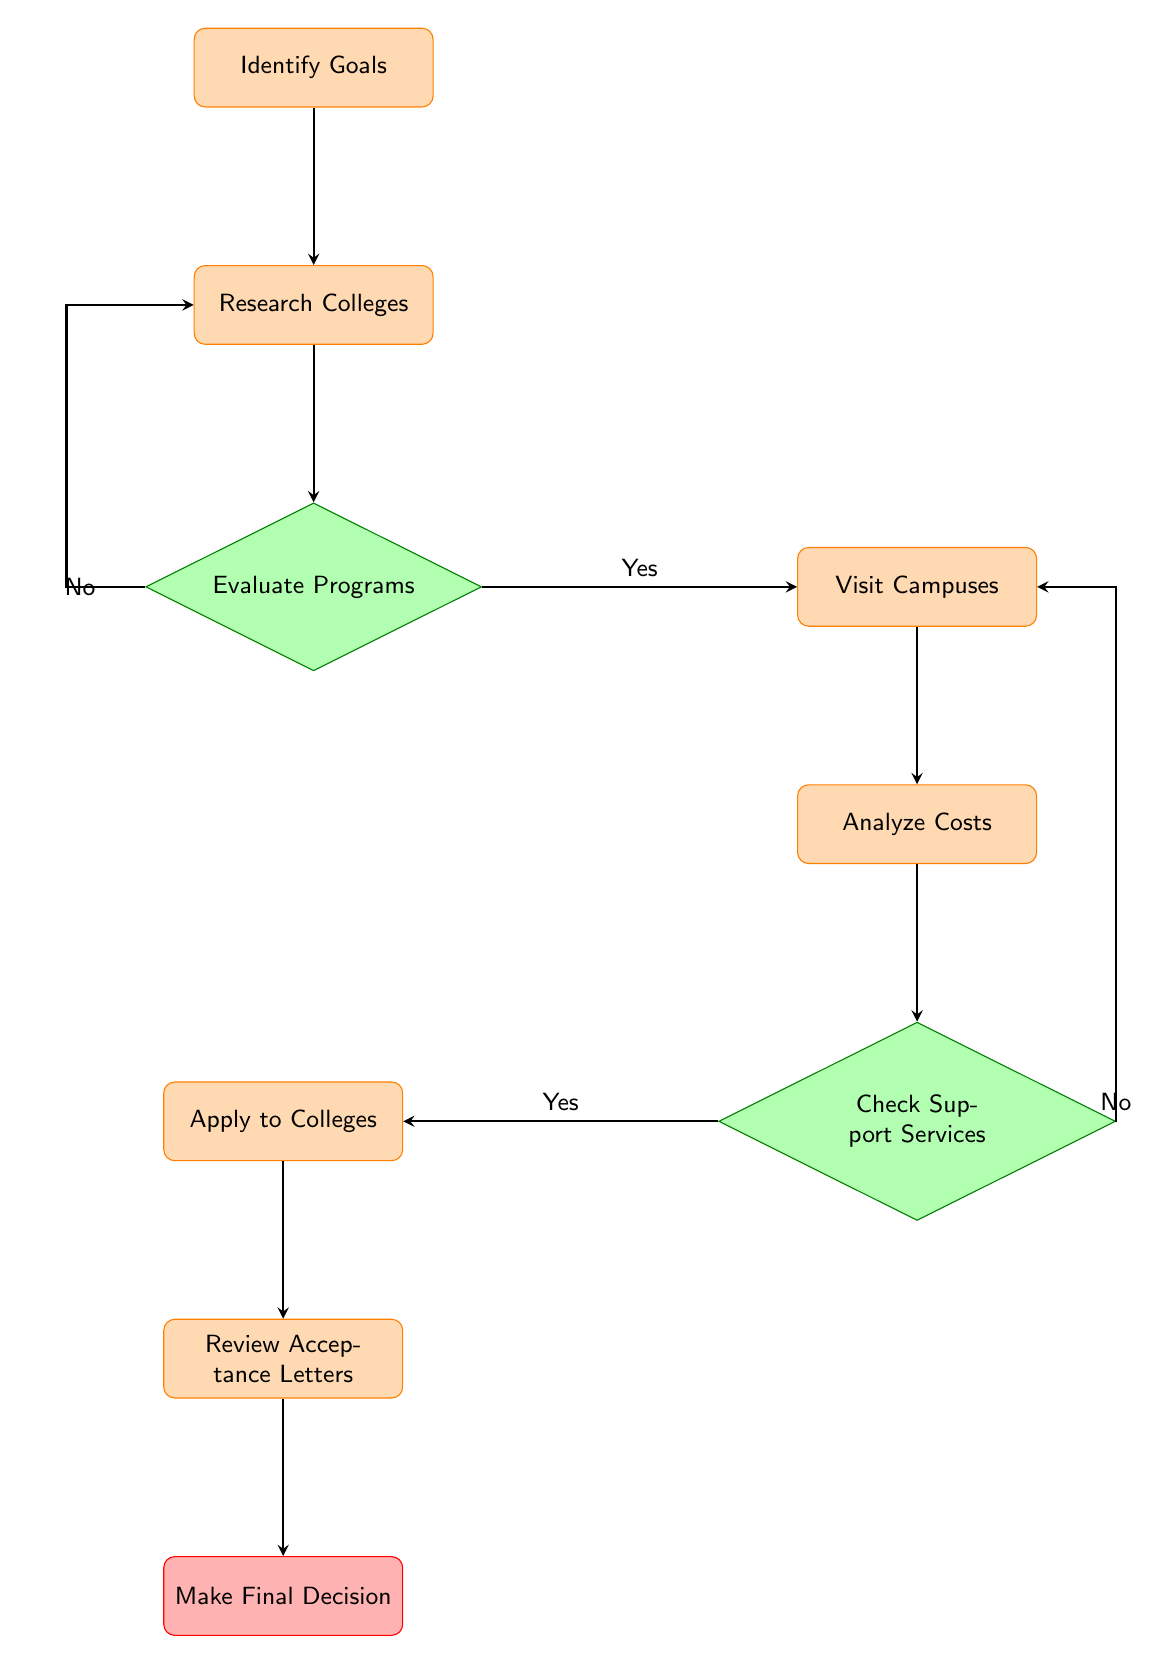What is the first step in the decision-making process for college selection? The first step is represented by the node "Identify Goals", which emphasizes discussing educational and career goals with the family.
Answer: Identify Goals How many decision nodes are present in the diagram? There are two decision nodes: "Evaluate Programs" and "Check Support Services", which require a yes or no answer.
Answer: 2 What action follows after conducting research about colleges? After researching colleges, the next action is to "Evaluate Programs" to check if the colleges align with career goals.
Answer: Evaluate Programs What is the outcome if a college program does not align with goals? If the program does not align with goals, the flow goes back to "Research Colleges" for further exploration of options.
Answer: Research Colleges What does "Analyze Costs" focus on in the college selection process? "Analyze Costs" focuses on comparing tuition, living expenses, and financial aid options for the shortlisted colleges.
Answer: Comparing costs What marker indicates that a college is worth applying to? The "Check Support Services" decision node indicates that if the support services meet the needs, one should proceed to "Apply to Colleges".
Answer: Yes What must occur before making a final decision? Before making a final decision, applicants need to review acceptance letters received from colleges they applied to.
Answer: Review Acceptance Letters Which step involves scheduling visits to the college campuses? "Visit Campuses" is the step where one schedules visits to those colleges they have shortlisted.
Answer: Visit Campuses 